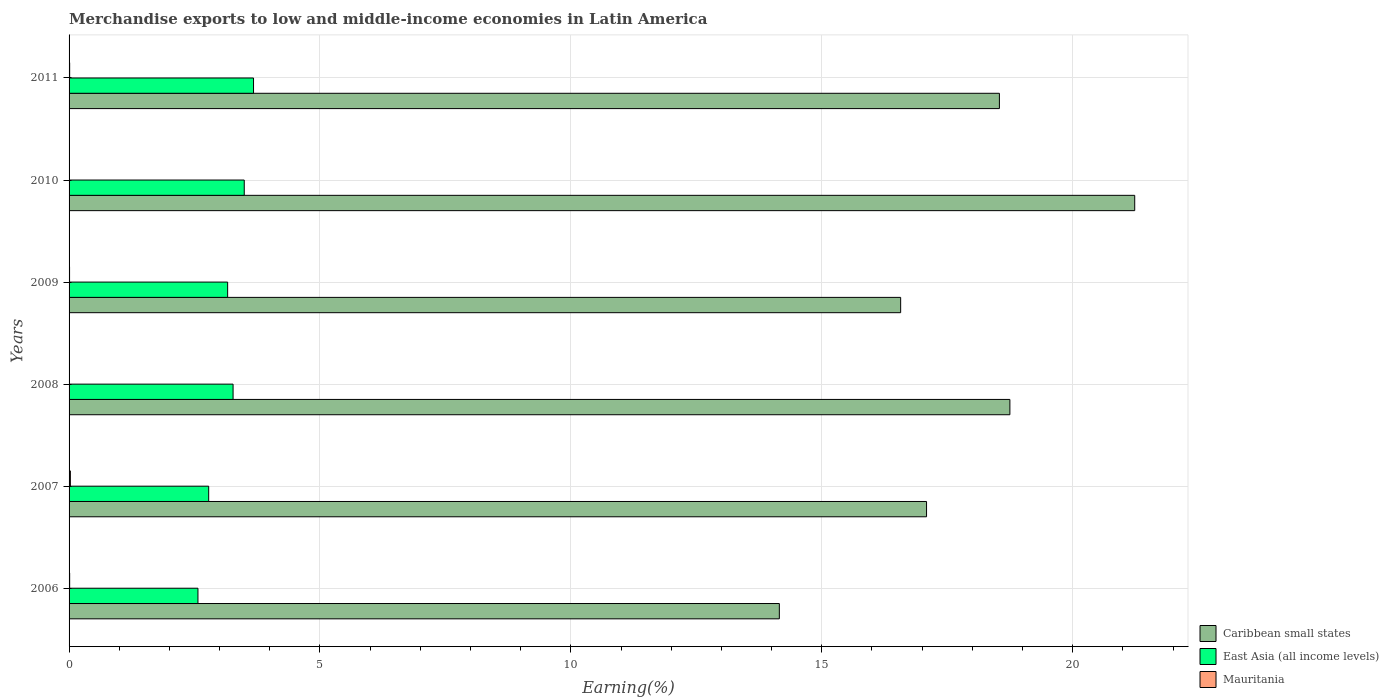How many different coloured bars are there?
Make the answer very short. 3. How many groups of bars are there?
Make the answer very short. 6. Are the number of bars per tick equal to the number of legend labels?
Your response must be concise. Yes. Are the number of bars on each tick of the Y-axis equal?
Ensure brevity in your answer.  Yes. What is the label of the 6th group of bars from the top?
Offer a terse response. 2006. In how many cases, is the number of bars for a given year not equal to the number of legend labels?
Offer a very short reply. 0. What is the percentage of amount earned from merchandise exports in Caribbean small states in 2011?
Offer a terse response. 18.54. Across all years, what is the maximum percentage of amount earned from merchandise exports in Mauritania?
Make the answer very short. 0.03. Across all years, what is the minimum percentage of amount earned from merchandise exports in Mauritania?
Offer a very short reply. 0. In which year was the percentage of amount earned from merchandise exports in Mauritania maximum?
Your answer should be very brief. 2007. In which year was the percentage of amount earned from merchandise exports in Mauritania minimum?
Your response must be concise. 2010. What is the total percentage of amount earned from merchandise exports in Caribbean small states in the graph?
Provide a succinct answer. 106.34. What is the difference between the percentage of amount earned from merchandise exports in East Asia (all income levels) in 2006 and that in 2008?
Ensure brevity in your answer.  -0.7. What is the difference between the percentage of amount earned from merchandise exports in Mauritania in 2009 and the percentage of amount earned from merchandise exports in Caribbean small states in 2007?
Your answer should be very brief. -17.08. What is the average percentage of amount earned from merchandise exports in Caribbean small states per year?
Give a very brief answer. 17.72. In the year 2007, what is the difference between the percentage of amount earned from merchandise exports in Caribbean small states and percentage of amount earned from merchandise exports in Mauritania?
Offer a very short reply. 17.06. What is the ratio of the percentage of amount earned from merchandise exports in Mauritania in 2007 to that in 2009?
Provide a short and direct response. 2.67. Is the percentage of amount earned from merchandise exports in Mauritania in 2006 less than that in 2010?
Your answer should be compact. No. What is the difference between the highest and the second highest percentage of amount earned from merchandise exports in East Asia (all income levels)?
Make the answer very short. 0.18. What is the difference between the highest and the lowest percentage of amount earned from merchandise exports in Caribbean small states?
Ensure brevity in your answer.  7.08. What does the 1st bar from the top in 2006 represents?
Offer a terse response. Mauritania. What does the 2nd bar from the bottom in 2009 represents?
Provide a short and direct response. East Asia (all income levels). How many bars are there?
Provide a succinct answer. 18. How many years are there in the graph?
Your answer should be very brief. 6. Does the graph contain any zero values?
Offer a very short reply. No. What is the title of the graph?
Offer a very short reply. Merchandise exports to low and middle-income economies in Latin America. What is the label or title of the X-axis?
Make the answer very short. Earning(%). What is the label or title of the Y-axis?
Ensure brevity in your answer.  Years. What is the Earning(%) in Caribbean small states in 2006?
Provide a short and direct response. 14.15. What is the Earning(%) in East Asia (all income levels) in 2006?
Provide a short and direct response. 2.57. What is the Earning(%) in Mauritania in 2006?
Offer a terse response. 0.01. What is the Earning(%) in Caribbean small states in 2007?
Provide a short and direct response. 17.09. What is the Earning(%) in East Asia (all income levels) in 2007?
Ensure brevity in your answer.  2.78. What is the Earning(%) in Mauritania in 2007?
Your answer should be very brief. 0.03. What is the Earning(%) of Caribbean small states in 2008?
Offer a terse response. 18.75. What is the Earning(%) in East Asia (all income levels) in 2008?
Give a very brief answer. 3.27. What is the Earning(%) of Mauritania in 2008?
Provide a succinct answer. 0.01. What is the Earning(%) in Caribbean small states in 2009?
Your answer should be very brief. 16.57. What is the Earning(%) of East Asia (all income levels) in 2009?
Your answer should be compact. 3.16. What is the Earning(%) of Mauritania in 2009?
Offer a terse response. 0.01. What is the Earning(%) in Caribbean small states in 2010?
Give a very brief answer. 21.24. What is the Earning(%) of East Asia (all income levels) in 2010?
Offer a terse response. 3.49. What is the Earning(%) in Mauritania in 2010?
Your answer should be very brief. 0. What is the Earning(%) of Caribbean small states in 2011?
Your response must be concise. 18.54. What is the Earning(%) of East Asia (all income levels) in 2011?
Offer a terse response. 3.68. What is the Earning(%) of Mauritania in 2011?
Give a very brief answer. 0.01. Across all years, what is the maximum Earning(%) of Caribbean small states?
Your answer should be very brief. 21.24. Across all years, what is the maximum Earning(%) in East Asia (all income levels)?
Your answer should be compact. 3.68. Across all years, what is the maximum Earning(%) of Mauritania?
Your answer should be very brief. 0.03. Across all years, what is the minimum Earning(%) in Caribbean small states?
Ensure brevity in your answer.  14.15. Across all years, what is the minimum Earning(%) in East Asia (all income levels)?
Your response must be concise. 2.57. Across all years, what is the minimum Earning(%) in Mauritania?
Your response must be concise. 0. What is the total Earning(%) in Caribbean small states in the graph?
Ensure brevity in your answer.  106.34. What is the total Earning(%) in East Asia (all income levels) in the graph?
Provide a succinct answer. 18.95. What is the total Earning(%) in Mauritania in the graph?
Offer a terse response. 0.07. What is the difference between the Earning(%) in Caribbean small states in 2006 and that in 2007?
Your answer should be very brief. -2.93. What is the difference between the Earning(%) in East Asia (all income levels) in 2006 and that in 2007?
Your answer should be very brief. -0.21. What is the difference between the Earning(%) in Mauritania in 2006 and that in 2007?
Your response must be concise. -0.01. What is the difference between the Earning(%) in Caribbean small states in 2006 and that in 2008?
Give a very brief answer. -4.59. What is the difference between the Earning(%) of Mauritania in 2006 and that in 2008?
Give a very brief answer. 0.01. What is the difference between the Earning(%) in Caribbean small states in 2006 and that in 2009?
Your answer should be compact. -2.42. What is the difference between the Earning(%) in East Asia (all income levels) in 2006 and that in 2009?
Offer a terse response. -0.59. What is the difference between the Earning(%) in Mauritania in 2006 and that in 2009?
Provide a succinct answer. 0. What is the difference between the Earning(%) in Caribbean small states in 2006 and that in 2010?
Make the answer very short. -7.08. What is the difference between the Earning(%) in East Asia (all income levels) in 2006 and that in 2010?
Make the answer very short. -0.92. What is the difference between the Earning(%) in Mauritania in 2006 and that in 2010?
Offer a very short reply. 0.01. What is the difference between the Earning(%) in Caribbean small states in 2006 and that in 2011?
Offer a terse response. -4.39. What is the difference between the Earning(%) of East Asia (all income levels) in 2006 and that in 2011?
Offer a very short reply. -1.11. What is the difference between the Earning(%) in Caribbean small states in 2007 and that in 2008?
Offer a terse response. -1.66. What is the difference between the Earning(%) of East Asia (all income levels) in 2007 and that in 2008?
Offer a terse response. -0.49. What is the difference between the Earning(%) in Mauritania in 2007 and that in 2008?
Provide a short and direct response. 0.02. What is the difference between the Earning(%) in Caribbean small states in 2007 and that in 2009?
Ensure brevity in your answer.  0.52. What is the difference between the Earning(%) of East Asia (all income levels) in 2007 and that in 2009?
Your answer should be compact. -0.38. What is the difference between the Earning(%) of Mauritania in 2007 and that in 2009?
Make the answer very short. 0.02. What is the difference between the Earning(%) in Caribbean small states in 2007 and that in 2010?
Keep it short and to the point. -4.15. What is the difference between the Earning(%) in East Asia (all income levels) in 2007 and that in 2010?
Your answer should be very brief. -0.71. What is the difference between the Earning(%) in Mauritania in 2007 and that in 2010?
Your response must be concise. 0.02. What is the difference between the Earning(%) in Caribbean small states in 2007 and that in 2011?
Ensure brevity in your answer.  -1.45. What is the difference between the Earning(%) in East Asia (all income levels) in 2007 and that in 2011?
Ensure brevity in your answer.  -0.89. What is the difference between the Earning(%) in Mauritania in 2007 and that in 2011?
Your answer should be very brief. 0.01. What is the difference between the Earning(%) in Caribbean small states in 2008 and that in 2009?
Your answer should be very brief. 2.18. What is the difference between the Earning(%) in East Asia (all income levels) in 2008 and that in 2009?
Offer a terse response. 0.11. What is the difference between the Earning(%) in Mauritania in 2008 and that in 2009?
Your answer should be compact. -0. What is the difference between the Earning(%) in Caribbean small states in 2008 and that in 2010?
Your response must be concise. -2.49. What is the difference between the Earning(%) of East Asia (all income levels) in 2008 and that in 2010?
Provide a short and direct response. -0.22. What is the difference between the Earning(%) in Mauritania in 2008 and that in 2010?
Give a very brief answer. 0. What is the difference between the Earning(%) of Caribbean small states in 2008 and that in 2011?
Provide a short and direct response. 0.21. What is the difference between the Earning(%) in East Asia (all income levels) in 2008 and that in 2011?
Your answer should be compact. -0.41. What is the difference between the Earning(%) in Mauritania in 2008 and that in 2011?
Your answer should be compact. -0.01. What is the difference between the Earning(%) of Caribbean small states in 2009 and that in 2010?
Your answer should be compact. -4.66. What is the difference between the Earning(%) in East Asia (all income levels) in 2009 and that in 2010?
Your answer should be very brief. -0.33. What is the difference between the Earning(%) of Mauritania in 2009 and that in 2010?
Provide a short and direct response. 0.01. What is the difference between the Earning(%) of Caribbean small states in 2009 and that in 2011?
Your answer should be very brief. -1.97. What is the difference between the Earning(%) in East Asia (all income levels) in 2009 and that in 2011?
Provide a short and direct response. -0.52. What is the difference between the Earning(%) of Mauritania in 2009 and that in 2011?
Your answer should be very brief. -0. What is the difference between the Earning(%) of Caribbean small states in 2010 and that in 2011?
Provide a succinct answer. 2.7. What is the difference between the Earning(%) in East Asia (all income levels) in 2010 and that in 2011?
Offer a very short reply. -0.18. What is the difference between the Earning(%) of Mauritania in 2010 and that in 2011?
Your answer should be compact. -0.01. What is the difference between the Earning(%) of Caribbean small states in 2006 and the Earning(%) of East Asia (all income levels) in 2007?
Offer a terse response. 11.37. What is the difference between the Earning(%) in Caribbean small states in 2006 and the Earning(%) in Mauritania in 2007?
Offer a very short reply. 14.13. What is the difference between the Earning(%) in East Asia (all income levels) in 2006 and the Earning(%) in Mauritania in 2007?
Provide a succinct answer. 2.54. What is the difference between the Earning(%) in Caribbean small states in 2006 and the Earning(%) in East Asia (all income levels) in 2008?
Offer a very short reply. 10.89. What is the difference between the Earning(%) in Caribbean small states in 2006 and the Earning(%) in Mauritania in 2008?
Ensure brevity in your answer.  14.15. What is the difference between the Earning(%) of East Asia (all income levels) in 2006 and the Earning(%) of Mauritania in 2008?
Ensure brevity in your answer.  2.56. What is the difference between the Earning(%) of Caribbean small states in 2006 and the Earning(%) of East Asia (all income levels) in 2009?
Provide a succinct answer. 10.99. What is the difference between the Earning(%) of Caribbean small states in 2006 and the Earning(%) of Mauritania in 2009?
Make the answer very short. 14.14. What is the difference between the Earning(%) in East Asia (all income levels) in 2006 and the Earning(%) in Mauritania in 2009?
Provide a short and direct response. 2.56. What is the difference between the Earning(%) in Caribbean small states in 2006 and the Earning(%) in East Asia (all income levels) in 2010?
Give a very brief answer. 10.66. What is the difference between the Earning(%) in Caribbean small states in 2006 and the Earning(%) in Mauritania in 2010?
Offer a very short reply. 14.15. What is the difference between the Earning(%) in East Asia (all income levels) in 2006 and the Earning(%) in Mauritania in 2010?
Ensure brevity in your answer.  2.57. What is the difference between the Earning(%) in Caribbean small states in 2006 and the Earning(%) in East Asia (all income levels) in 2011?
Your response must be concise. 10.48. What is the difference between the Earning(%) in Caribbean small states in 2006 and the Earning(%) in Mauritania in 2011?
Keep it short and to the point. 14.14. What is the difference between the Earning(%) of East Asia (all income levels) in 2006 and the Earning(%) of Mauritania in 2011?
Make the answer very short. 2.56. What is the difference between the Earning(%) in Caribbean small states in 2007 and the Earning(%) in East Asia (all income levels) in 2008?
Ensure brevity in your answer.  13.82. What is the difference between the Earning(%) of Caribbean small states in 2007 and the Earning(%) of Mauritania in 2008?
Provide a short and direct response. 17.08. What is the difference between the Earning(%) of East Asia (all income levels) in 2007 and the Earning(%) of Mauritania in 2008?
Your response must be concise. 2.78. What is the difference between the Earning(%) of Caribbean small states in 2007 and the Earning(%) of East Asia (all income levels) in 2009?
Give a very brief answer. 13.93. What is the difference between the Earning(%) of Caribbean small states in 2007 and the Earning(%) of Mauritania in 2009?
Keep it short and to the point. 17.08. What is the difference between the Earning(%) of East Asia (all income levels) in 2007 and the Earning(%) of Mauritania in 2009?
Your answer should be compact. 2.77. What is the difference between the Earning(%) in Caribbean small states in 2007 and the Earning(%) in East Asia (all income levels) in 2010?
Give a very brief answer. 13.6. What is the difference between the Earning(%) in Caribbean small states in 2007 and the Earning(%) in Mauritania in 2010?
Give a very brief answer. 17.09. What is the difference between the Earning(%) of East Asia (all income levels) in 2007 and the Earning(%) of Mauritania in 2010?
Offer a terse response. 2.78. What is the difference between the Earning(%) of Caribbean small states in 2007 and the Earning(%) of East Asia (all income levels) in 2011?
Give a very brief answer. 13.41. What is the difference between the Earning(%) in Caribbean small states in 2007 and the Earning(%) in Mauritania in 2011?
Offer a very short reply. 17.08. What is the difference between the Earning(%) of East Asia (all income levels) in 2007 and the Earning(%) of Mauritania in 2011?
Provide a succinct answer. 2.77. What is the difference between the Earning(%) of Caribbean small states in 2008 and the Earning(%) of East Asia (all income levels) in 2009?
Make the answer very short. 15.59. What is the difference between the Earning(%) of Caribbean small states in 2008 and the Earning(%) of Mauritania in 2009?
Ensure brevity in your answer.  18.74. What is the difference between the Earning(%) of East Asia (all income levels) in 2008 and the Earning(%) of Mauritania in 2009?
Make the answer very short. 3.26. What is the difference between the Earning(%) of Caribbean small states in 2008 and the Earning(%) of East Asia (all income levels) in 2010?
Offer a very short reply. 15.26. What is the difference between the Earning(%) in Caribbean small states in 2008 and the Earning(%) in Mauritania in 2010?
Ensure brevity in your answer.  18.75. What is the difference between the Earning(%) in East Asia (all income levels) in 2008 and the Earning(%) in Mauritania in 2010?
Keep it short and to the point. 3.27. What is the difference between the Earning(%) of Caribbean small states in 2008 and the Earning(%) of East Asia (all income levels) in 2011?
Offer a very short reply. 15.07. What is the difference between the Earning(%) of Caribbean small states in 2008 and the Earning(%) of Mauritania in 2011?
Make the answer very short. 18.74. What is the difference between the Earning(%) of East Asia (all income levels) in 2008 and the Earning(%) of Mauritania in 2011?
Offer a terse response. 3.26. What is the difference between the Earning(%) in Caribbean small states in 2009 and the Earning(%) in East Asia (all income levels) in 2010?
Provide a short and direct response. 13.08. What is the difference between the Earning(%) of Caribbean small states in 2009 and the Earning(%) of Mauritania in 2010?
Offer a terse response. 16.57. What is the difference between the Earning(%) in East Asia (all income levels) in 2009 and the Earning(%) in Mauritania in 2010?
Offer a very short reply. 3.16. What is the difference between the Earning(%) of Caribbean small states in 2009 and the Earning(%) of East Asia (all income levels) in 2011?
Keep it short and to the point. 12.9. What is the difference between the Earning(%) of Caribbean small states in 2009 and the Earning(%) of Mauritania in 2011?
Ensure brevity in your answer.  16.56. What is the difference between the Earning(%) in East Asia (all income levels) in 2009 and the Earning(%) in Mauritania in 2011?
Your answer should be very brief. 3.15. What is the difference between the Earning(%) of Caribbean small states in 2010 and the Earning(%) of East Asia (all income levels) in 2011?
Give a very brief answer. 17.56. What is the difference between the Earning(%) in Caribbean small states in 2010 and the Earning(%) in Mauritania in 2011?
Make the answer very short. 21.22. What is the difference between the Earning(%) in East Asia (all income levels) in 2010 and the Earning(%) in Mauritania in 2011?
Offer a terse response. 3.48. What is the average Earning(%) in Caribbean small states per year?
Keep it short and to the point. 17.72. What is the average Earning(%) in East Asia (all income levels) per year?
Offer a terse response. 3.16. What is the average Earning(%) in Mauritania per year?
Your answer should be compact. 0.01. In the year 2006, what is the difference between the Earning(%) of Caribbean small states and Earning(%) of East Asia (all income levels)?
Offer a very short reply. 11.59. In the year 2006, what is the difference between the Earning(%) of Caribbean small states and Earning(%) of Mauritania?
Keep it short and to the point. 14.14. In the year 2006, what is the difference between the Earning(%) of East Asia (all income levels) and Earning(%) of Mauritania?
Make the answer very short. 2.56. In the year 2007, what is the difference between the Earning(%) in Caribbean small states and Earning(%) in East Asia (all income levels)?
Your answer should be compact. 14.31. In the year 2007, what is the difference between the Earning(%) of Caribbean small states and Earning(%) of Mauritania?
Ensure brevity in your answer.  17.06. In the year 2007, what is the difference between the Earning(%) in East Asia (all income levels) and Earning(%) in Mauritania?
Your answer should be very brief. 2.76. In the year 2008, what is the difference between the Earning(%) of Caribbean small states and Earning(%) of East Asia (all income levels)?
Your answer should be very brief. 15.48. In the year 2008, what is the difference between the Earning(%) of Caribbean small states and Earning(%) of Mauritania?
Provide a succinct answer. 18.74. In the year 2008, what is the difference between the Earning(%) of East Asia (all income levels) and Earning(%) of Mauritania?
Offer a terse response. 3.26. In the year 2009, what is the difference between the Earning(%) in Caribbean small states and Earning(%) in East Asia (all income levels)?
Your answer should be very brief. 13.41. In the year 2009, what is the difference between the Earning(%) in Caribbean small states and Earning(%) in Mauritania?
Provide a short and direct response. 16.56. In the year 2009, what is the difference between the Earning(%) of East Asia (all income levels) and Earning(%) of Mauritania?
Make the answer very short. 3.15. In the year 2010, what is the difference between the Earning(%) in Caribbean small states and Earning(%) in East Asia (all income levels)?
Keep it short and to the point. 17.75. In the year 2010, what is the difference between the Earning(%) in Caribbean small states and Earning(%) in Mauritania?
Offer a very short reply. 21.23. In the year 2010, what is the difference between the Earning(%) of East Asia (all income levels) and Earning(%) of Mauritania?
Provide a short and direct response. 3.49. In the year 2011, what is the difference between the Earning(%) in Caribbean small states and Earning(%) in East Asia (all income levels)?
Give a very brief answer. 14.86. In the year 2011, what is the difference between the Earning(%) of Caribbean small states and Earning(%) of Mauritania?
Your answer should be compact. 18.53. In the year 2011, what is the difference between the Earning(%) of East Asia (all income levels) and Earning(%) of Mauritania?
Provide a succinct answer. 3.66. What is the ratio of the Earning(%) in Caribbean small states in 2006 to that in 2007?
Keep it short and to the point. 0.83. What is the ratio of the Earning(%) in East Asia (all income levels) in 2006 to that in 2007?
Provide a succinct answer. 0.92. What is the ratio of the Earning(%) in Mauritania in 2006 to that in 2007?
Your answer should be very brief. 0.45. What is the ratio of the Earning(%) in Caribbean small states in 2006 to that in 2008?
Give a very brief answer. 0.75. What is the ratio of the Earning(%) in East Asia (all income levels) in 2006 to that in 2008?
Your answer should be very brief. 0.79. What is the ratio of the Earning(%) of Mauritania in 2006 to that in 2008?
Give a very brief answer. 1.82. What is the ratio of the Earning(%) in Caribbean small states in 2006 to that in 2009?
Your answer should be compact. 0.85. What is the ratio of the Earning(%) in East Asia (all income levels) in 2006 to that in 2009?
Your answer should be compact. 0.81. What is the ratio of the Earning(%) in Mauritania in 2006 to that in 2009?
Make the answer very short. 1.2. What is the ratio of the Earning(%) in Caribbean small states in 2006 to that in 2010?
Ensure brevity in your answer.  0.67. What is the ratio of the Earning(%) in East Asia (all income levels) in 2006 to that in 2010?
Offer a very short reply. 0.74. What is the ratio of the Earning(%) of Mauritania in 2006 to that in 2010?
Ensure brevity in your answer.  4.19. What is the ratio of the Earning(%) of Caribbean small states in 2006 to that in 2011?
Offer a terse response. 0.76. What is the ratio of the Earning(%) in East Asia (all income levels) in 2006 to that in 2011?
Your response must be concise. 0.7. What is the ratio of the Earning(%) in Mauritania in 2006 to that in 2011?
Offer a very short reply. 1.02. What is the ratio of the Earning(%) of Caribbean small states in 2007 to that in 2008?
Offer a terse response. 0.91. What is the ratio of the Earning(%) in East Asia (all income levels) in 2007 to that in 2008?
Keep it short and to the point. 0.85. What is the ratio of the Earning(%) of Mauritania in 2007 to that in 2008?
Your answer should be compact. 4.04. What is the ratio of the Earning(%) of Caribbean small states in 2007 to that in 2009?
Your answer should be compact. 1.03. What is the ratio of the Earning(%) in East Asia (all income levels) in 2007 to that in 2009?
Provide a succinct answer. 0.88. What is the ratio of the Earning(%) in Mauritania in 2007 to that in 2009?
Provide a short and direct response. 2.67. What is the ratio of the Earning(%) in Caribbean small states in 2007 to that in 2010?
Ensure brevity in your answer.  0.8. What is the ratio of the Earning(%) in East Asia (all income levels) in 2007 to that in 2010?
Make the answer very short. 0.8. What is the ratio of the Earning(%) of Mauritania in 2007 to that in 2010?
Your answer should be compact. 9.3. What is the ratio of the Earning(%) of Caribbean small states in 2007 to that in 2011?
Provide a short and direct response. 0.92. What is the ratio of the Earning(%) of East Asia (all income levels) in 2007 to that in 2011?
Your answer should be compact. 0.76. What is the ratio of the Earning(%) in Mauritania in 2007 to that in 2011?
Offer a terse response. 2.25. What is the ratio of the Earning(%) of Caribbean small states in 2008 to that in 2009?
Your answer should be very brief. 1.13. What is the ratio of the Earning(%) in East Asia (all income levels) in 2008 to that in 2009?
Give a very brief answer. 1.03. What is the ratio of the Earning(%) in Mauritania in 2008 to that in 2009?
Make the answer very short. 0.66. What is the ratio of the Earning(%) of Caribbean small states in 2008 to that in 2010?
Ensure brevity in your answer.  0.88. What is the ratio of the Earning(%) of East Asia (all income levels) in 2008 to that in 2010?
Your answer should be very brief. 0.94. What is the ratio of the Earning(%) of Mauritania in 2008 to that in 2010?
Keep it short and to the point. 2.3. What is the ratio of the Earning(%) of Caribbean small states in 2008 to that in 2011?
Ensure brevity in your answer.  1.01. What is the ratio of the Earning(%) of East Asia (all income levels) in 2008 to that in 2011?
Provide a succinct answer. 0.89. What is the ratio of the Earning(%) in Mauritania in 2008 to that in 2011?
Your answer should be compact. 0.56. What is the ratio of the Earning(%) of Caribbean small states in 2009 to that in 2010?
Provide a short and direct response. 0.78. What is the ratio of the Earning(%) in East Asia (all income levels) in 2009 to that in 2010?
Make the answer very short. 0.91. What is the ratio of the Earning(%) of Mauritania in 2009 to that in 2010?
Provide a short and direct response. 3.49. What is the ratio of the Earning(%) of Caribbean small states in 2009 to that in 2011?
Your response must be concise. 0.89. What is the ratio of the Earning(%) in East Asia (all income levels) in 2009 to that in 2011?
Your response must be concise. 0.86. What is the ratio of the Earning(%) in Mauritania in 2009 to that in 2011?
Give a very brief answer. 0.85. What is the ratio of the Earning(%) in Caribbean small states in 2010 to that in 2011?
Provide a short and direct response. 1.15. What is the ratio of the Earning(%) in East Asia (all income levels) in 2010 to that in 2011?
Offer a very short reply. 0.95. What is the ratio of the Earning(%) in Mauritania in 2010 to that in 2011?
Provide a short and direct response. 0.24. What is the difference between the highest and the second highest Earning(%) of Caribbean small states?
Offer a terse response. 2.49. What is the difference between the highest and the second highest Earning(%) in East Asia (all income levels)?
Provide a short and direct response. 0.18. What is the difference between the highest and the second highest Earning(%) in Mauritania?
Offer a terse response. 0.01. What is the difference between the highest and the lowest Earning(%) of Caribbean small states?
Provide a short and direct response. 7.08. What is the difference between the highest and the lowest Earning(%) in East Asia (all income levels)?
Keep it short and to the point. 1.11. What is the difference between the highest and the lowest Earning(%) in Mauritania?
Offer a very short reply. 0.02. 